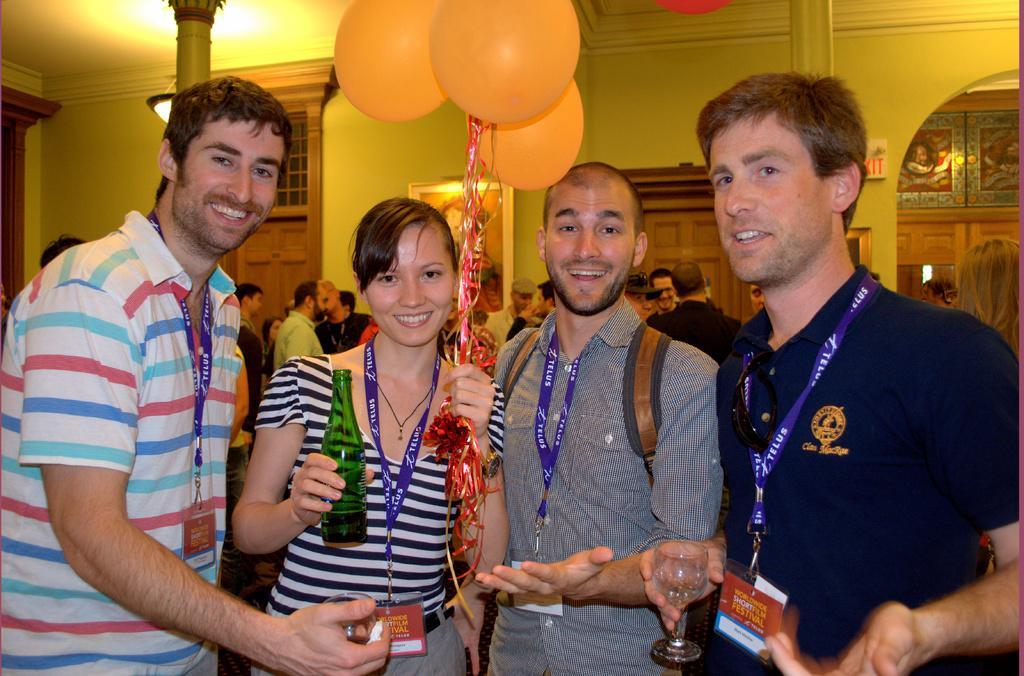In one or two sentences, can you explain what this image depicts? In the image it looks like a party and there are four people in the foreground, they are standing and posing for the photo, behind them there are many other people, in the background there is a wall and in between the wall there are two doors and there is a frame attached to the wall. 